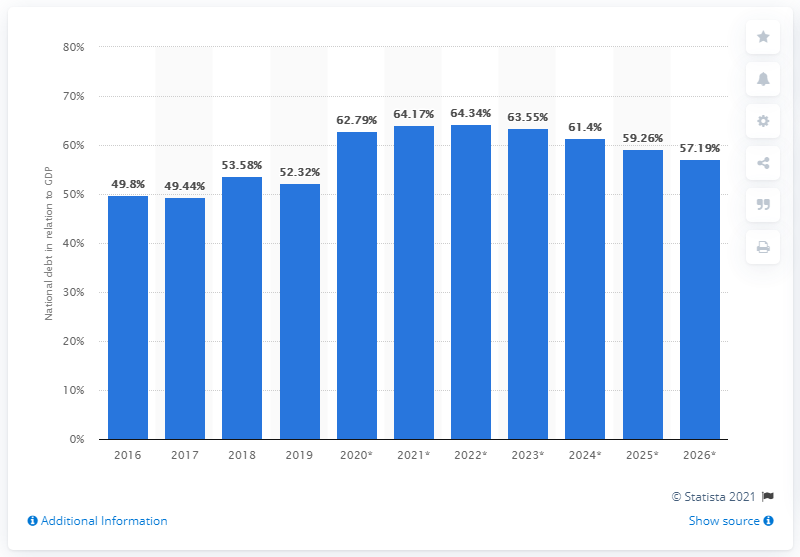Give some essential details in this illustration. In 2019, the national debt of Colombia accounted for 52.32% of the country's Gross Domestic Product (GDP). 